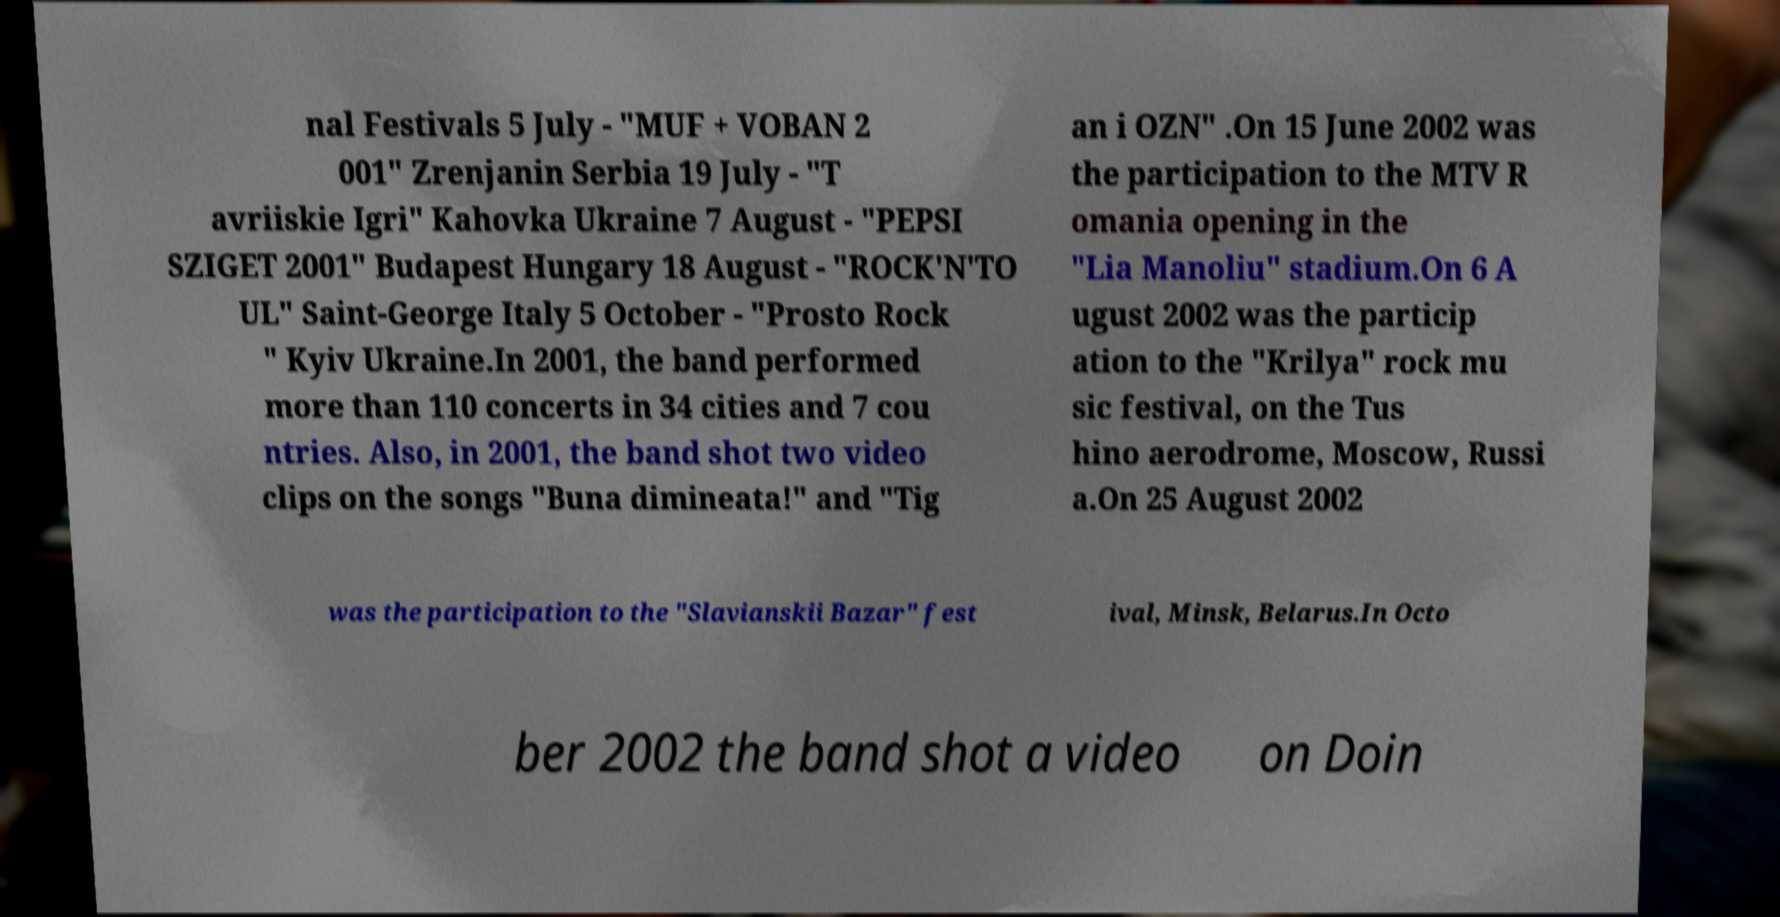There's text embedded in this image that I need extracted. Can you transcribe it verbatim? nal Festivals 5 July - "MUF + VOBAN 2 001" Zrenjanin Serbia 19 July - "T avriiskie Igri" Kahovka Ukraine 7 August - "PEPSI SZIGET 2001" Budapest Hungary 18 August - "ROCK'N'TO UL" Saint-George Italy 5 October - "Prosto Rock " Kyiv Ukraine.In 2001, the band performed more than 110 concerts in 34 cities and 7 cou ntries. Also, in 2001, the band shot two video clips on the songs "Buna dimineata!" and "Tig an i OZN" .On 15 June 2002 was the participation to the MTV R omania opening in the "Lia Manoliu" stadium.On 6 A ugust 2002 was the particip ation to the "Krilya" rock mu sic festival, on the Tus hino aerodrome, Moscow, Russi a.On 25 August 2002 was the participation to the "Slavianskii Bazar" fest ival, Minsk, Belarus.In Octo ber 2002 the band shot a video on Doin 